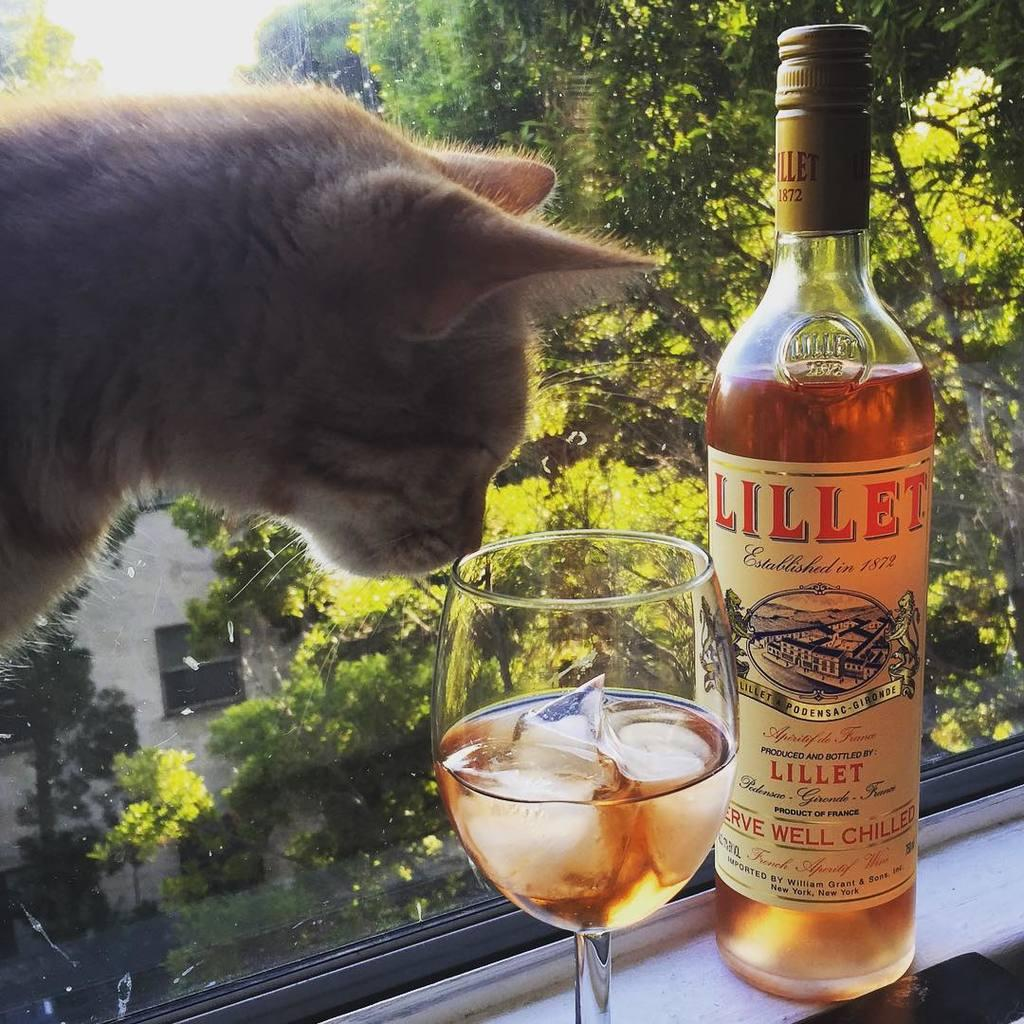<image>
Offer a succinct explanation of the picture presented. A cat beside a glass of wine that is beside a bottle of Lillet wine. 